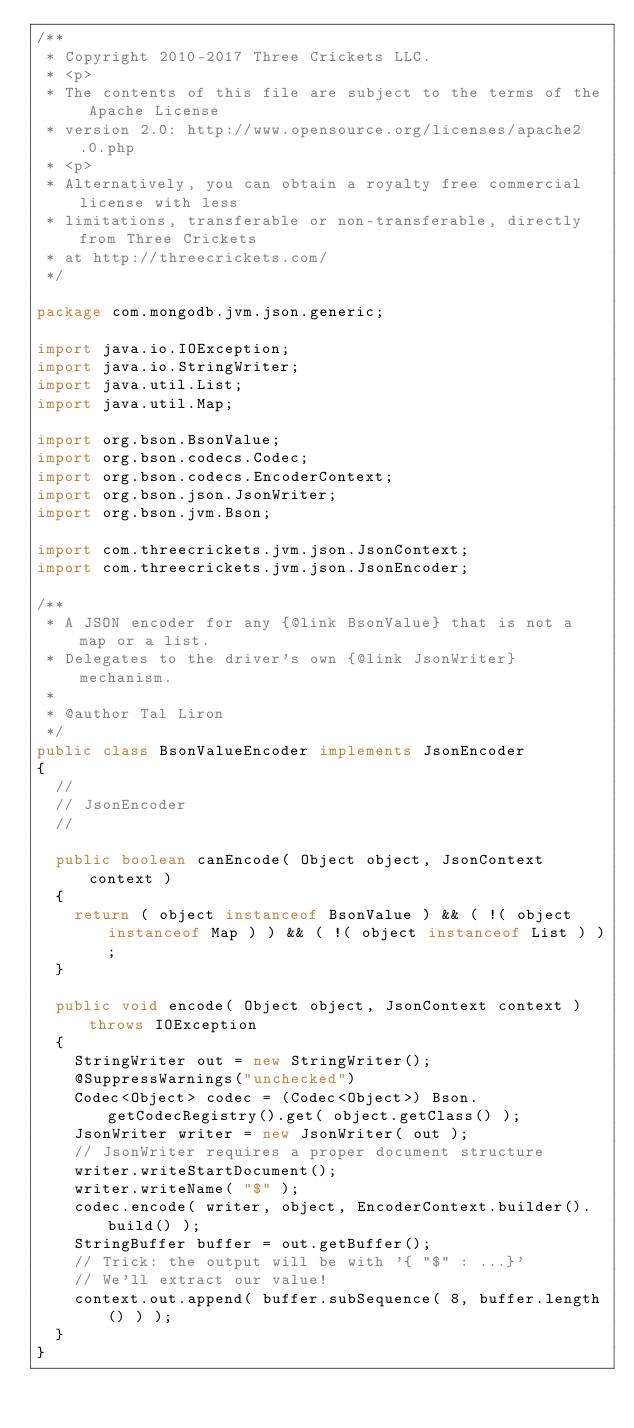Convert code to text. <code><loc_0><loc_0><loc_500><loc_500><_Java_>/**
 * Copyright 2010-2017 Three Crickets LLC.
 * <p>
 * The contents of this file are subject to the terms of the Apache License
 * version 2.0: http://www.opensource.org/licenses/apache2.0.php
 * <p>
 * Alternatively, you can obtain a royalty free commercial license with less
 * limitations, transferable or non-transferable, directly from Three Crickets
 * at http://threecrickets.com/
 */

package com.mongodb.jvm.json.generic;

import java.io.IOException;
import java.io.StringWriter;
import java.util.List;
import java.util.Map;

import org.bson.BsonValue;
import org.bson.codecs.Codec;
import org.bson.codecs.EncoderContext;
import org.bson.json.JsonWriter;
import org.bson.jvm.Bson;

import com.threecrickets.jvm.json.JsonContext;
import com.threecrickets.jvm.json.JsonEncoder;

/**
 * A JSON encoder for any {@link BsonValue} that is not a map or a list.
 * Delegates to the driver's own {@link JsonWriter} mechanism.
 * 
 * @author Tal Liron
 */
public class BsonValueEncoder implements JsonEncoder
{
	//
	// JsonEncoder
	//

	public boolean canEncode( Object object, JsonContext context )
	{
		return ( object instanceof BsonValue ) && ( !( object instanceof Map ) ) && ( !( object instanceof List ) );
	}

	public void encode( Object object, JsonContext context ) throws IOException
	{
		StringWriter out = new StringWriter();
		@SuppressWarnings("unchecked")
		Codec<Object> codec = (Codec<Object>) Bson.getCodecRegistry().get( object.getClass() );
		JsonWriter writer = new JsonWriter( out );
		// JsonWriter requires a proper document structure
		writer.writeStartDocument();
		writer.writeName( "$" );
		codec.encode( writer, object, EncoderContext.builder().build() );
		StringBuffer buffer = out.getBuffer();
		// Trick: the output will be with '{ "$" : ...}'
		// We'll extract our value!
		context.out.append( buffer.subSequence( 8, buffer.length() ) );
	}
}
</code> 